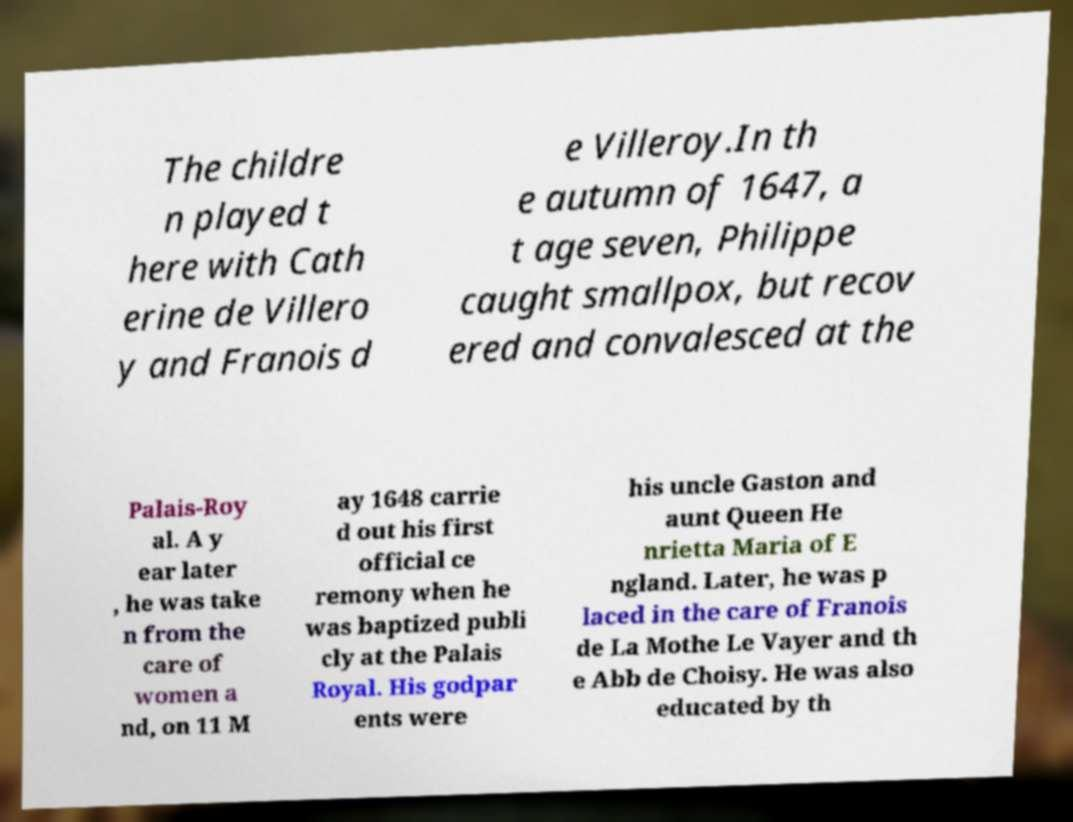Can you read and provide the text displayed in the image?This photo seems to have some interesting text. Can you extract and type it out for me? The childre n played t here with Cath erine de Villero y and Franois d e Villeroy.In th e autumn of 1647, a t age seven, Philippe caught smallpox, but recov ered and convalesced at the Palais-Roy al. A y ear later , he was take n from the care of women a nd, on 11 M ay 1648 carrie d out his first official ce remony when he was baptized publi cly at the Palais Royal. His godpar ents were his uncle Gaston and aunt Queen He nrietta Maria of E ngland. Later, he was p laced in the care of Franois de La Mothe Le Vayer and th e Abb de Choisy. He was also educated by th 